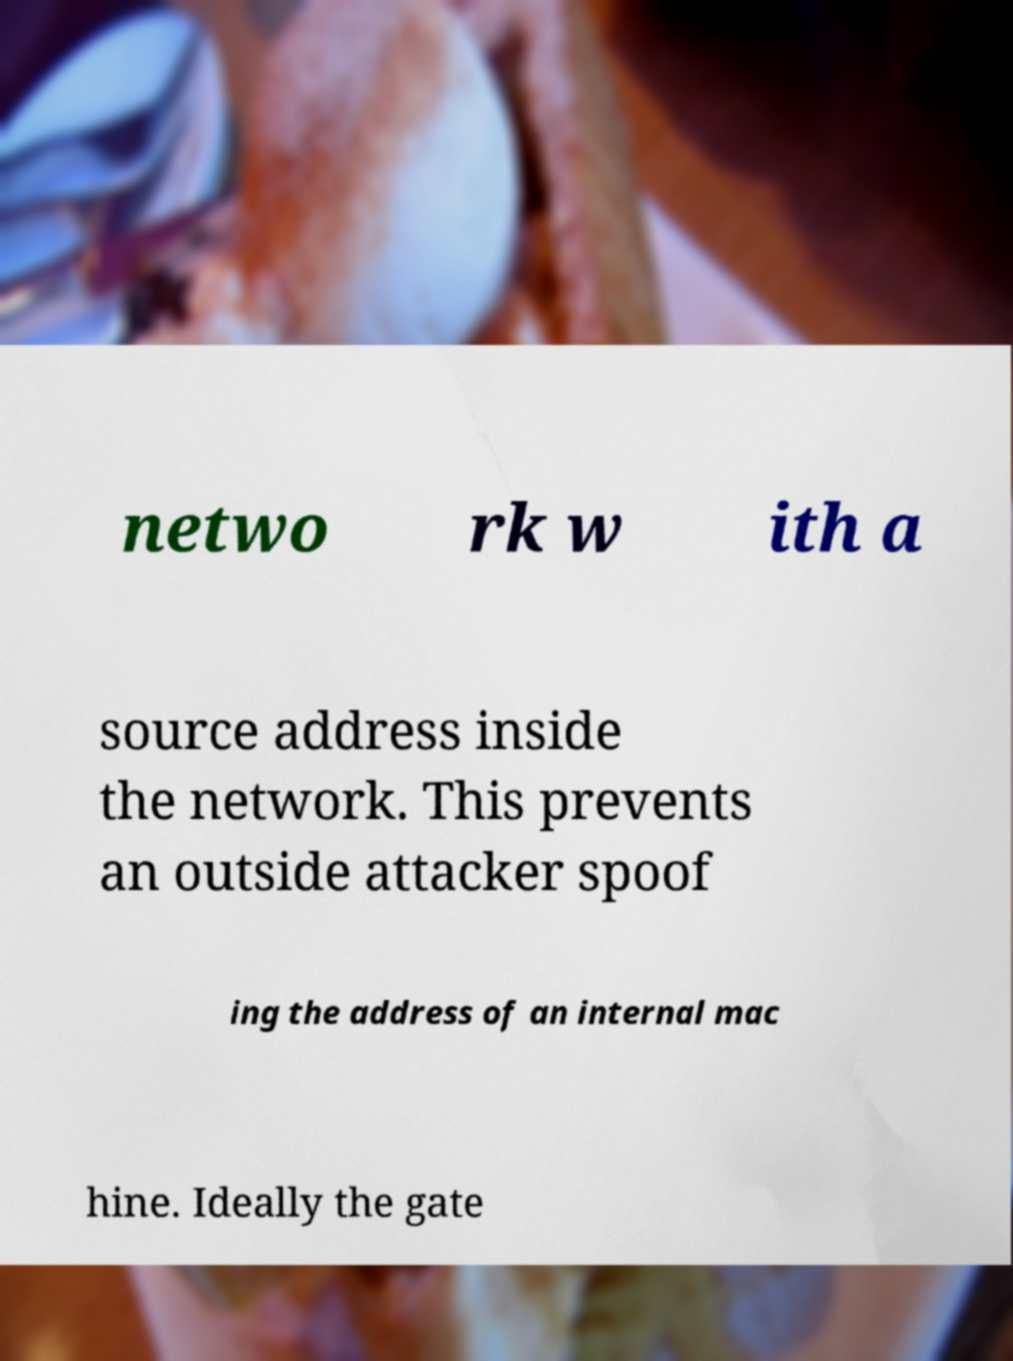Can you accurately transcribe the text from the provided image for me? netwo rk w ith a source address inside the network. This prevents an outside attacker spoof ing the address of an internal mac hine. Ideally the gate 